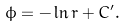Convert formula to latex. <formula><loc_0><loc_0><loc_500><loc_500>\phi = - \ln r + C ^ { \prime } .</formula> 